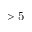<formula> <loc_0><loc_0><loc_500><loc_500>> 5</formula> 